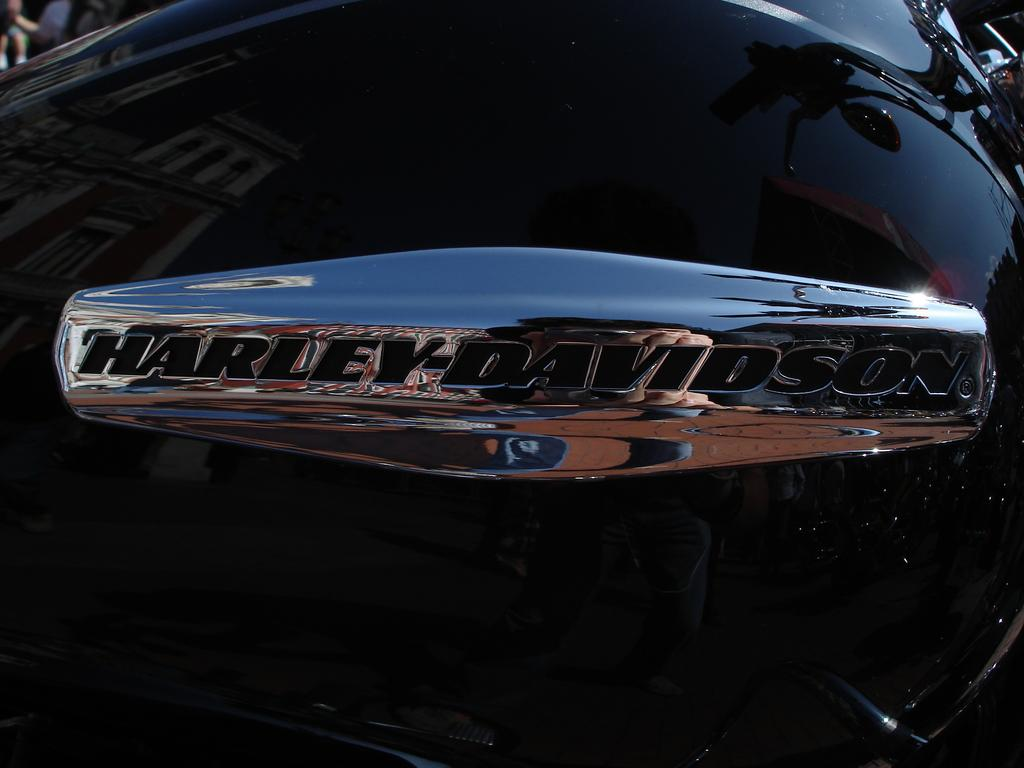What is featured in the image that represents a brand? There is a brand logo in the image. What is the color of the vehicle that displays the brand logo? The brand logo is on a black vehicle. How many iron bars are present in the image? There is no mention of iron bars in the image, so it is not possible to determine their presence or quantity. 